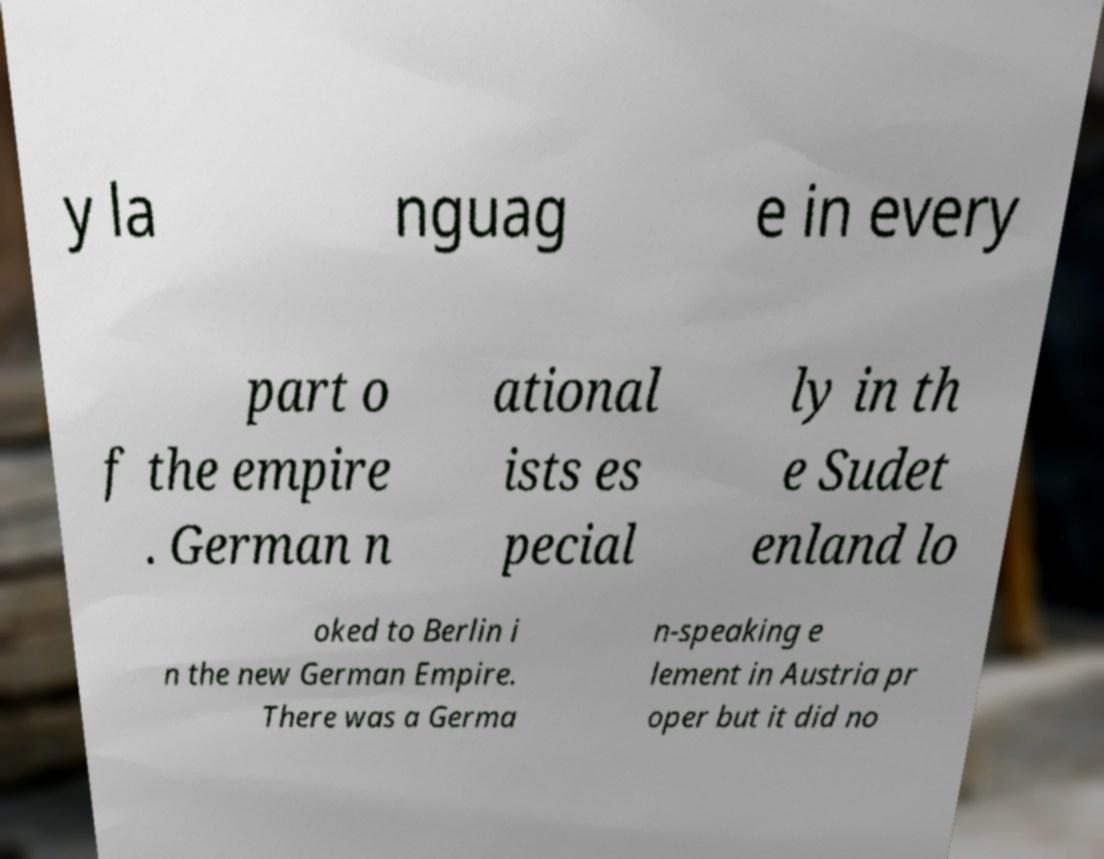Can you accurately transcribe the text from the provided image for me? y la nguag e in every part o f the empire . German n ational ists es pecial ly in th e Sudet enland lo oked to Berlin i n the new German Empire. There was a Germa n-speaking e lement in Austria pr oper but it did no 